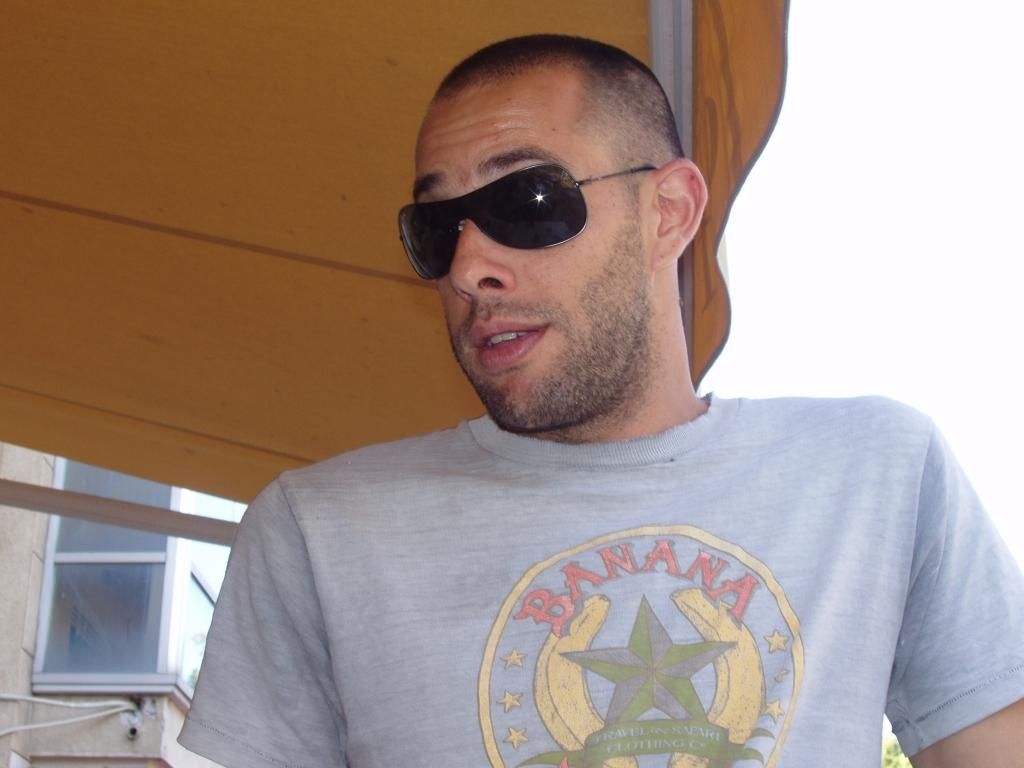Who is present in the image? There is a man in the image. What is the man wearing on his face? The man is wearing goggles. What type of clothing is the man wearing on his upper body? The man is wearing a t-shirt. What can be seen in the background of the image? There is a glass window in the background of the image. What type of shelter is visible in the image? There is a tent visible in the image. What type of quiver is the man carrying in the image? There is no quiver present in the image; the man is not carrying any such item. Who is the man's uncle in the image? The image does not provide any information about the man's family, so it is impossible to determine who his uncle might be. 